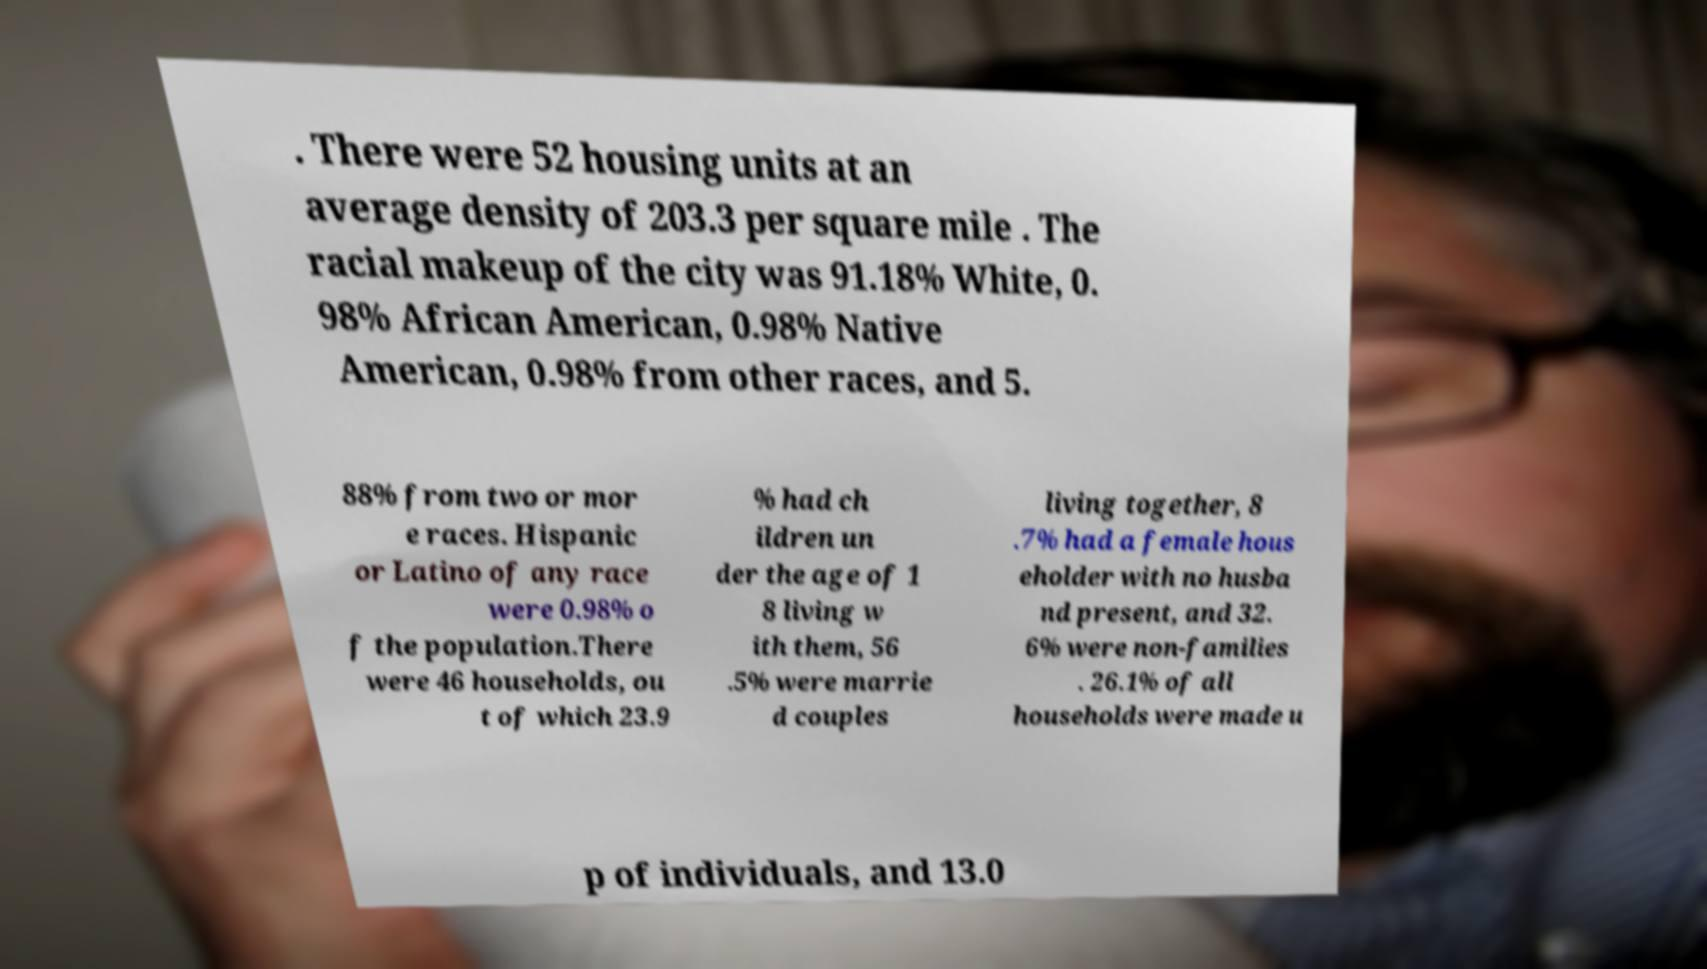For documentation purposes, I need the text within this image transcribed. Could you provide that? . There were 52 housing units at an average density of 203.3 per square mile . The racial makeup of the city was 91.18% White, 0. 98% African American, 0.98% Native American, 0.98% from other races, and 5. 88% from two or mor e races. Hispanic or Latino of any race were 0.98% o f the population.There were 46 households, ou t of which 23.9 % had ch ildren un der the age of 1 8 living w ith them, 56 .5% were marrie d couples living together, 8 .7% had a female hous eholder with no husba nd present, and 32. 6% were non-families . 26.1% of all households were made u p of individuals, and 13.0 